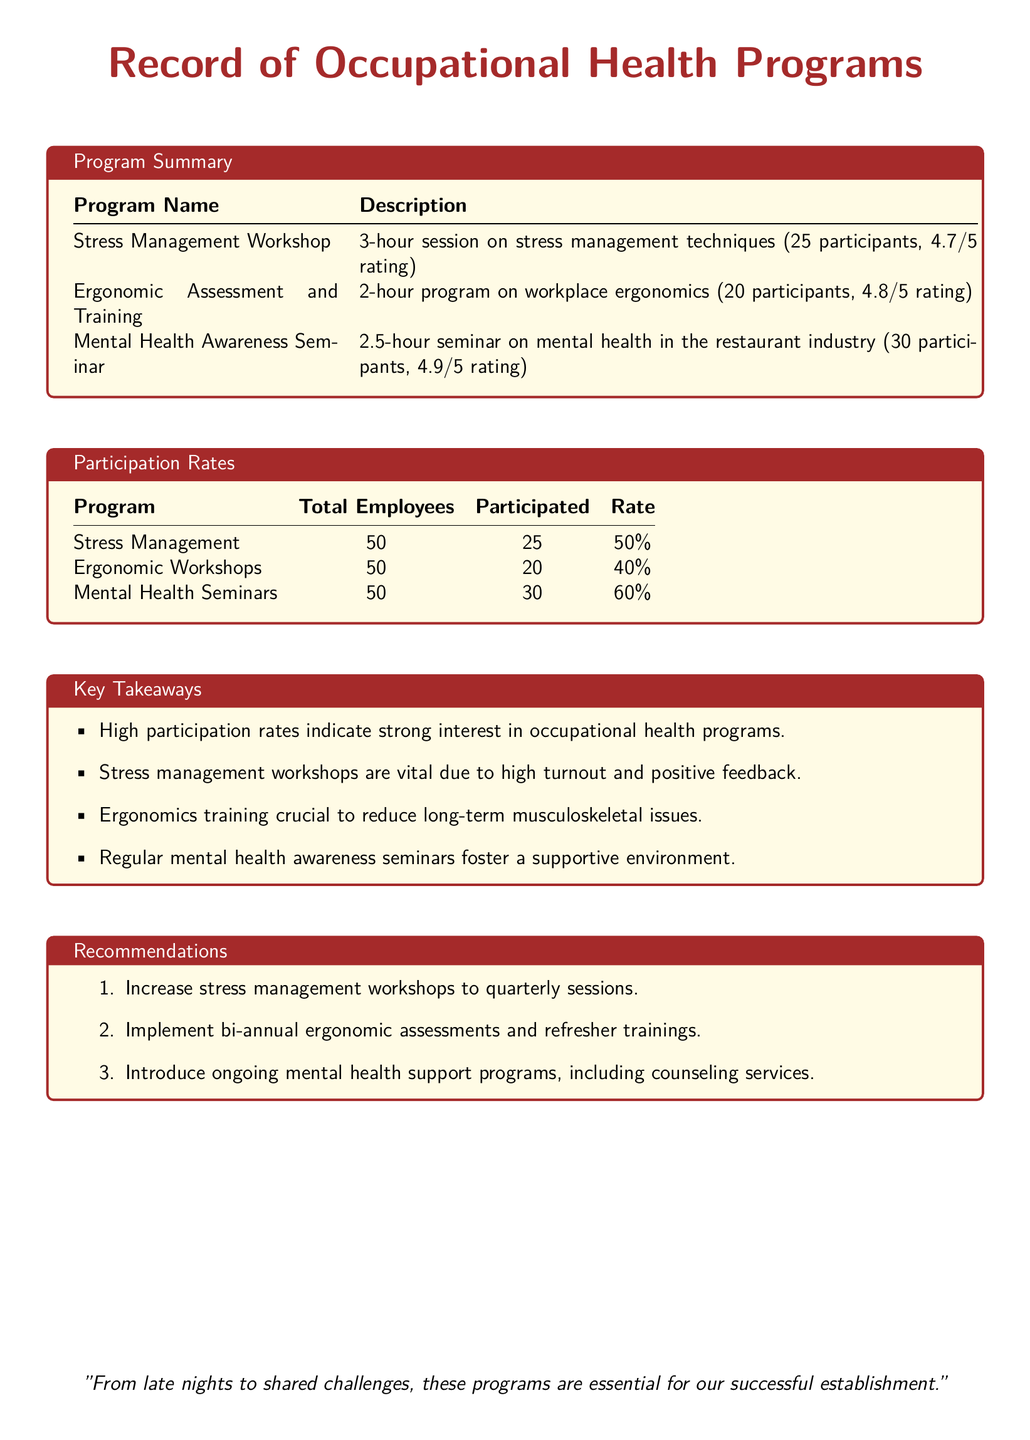what is the average rating of the Stress Management Workshop? The average rating of the Stress Management Workshop is given as 4.7 out of 5 in the document.
Answer: 4.7/5 how many participants attended the Ergonomic Workshops? The document states that there were 20 participants in the Ergonomic Workshops.
Answer: 20 what is the participation rate for Mental Health Seminars? The participation rate for Mental Health Seminars is noted as 60% in the participation rates section.
Answer: 60% which program had the highest rating? The program with the highest rating is the Mental Health Awareness Seminar at 4.9 out of 5.
Answer: 4.9/5 how often should stress management workshops be held according to the recommendations? According to the recommendations, stress management workshops should be held quarterly.
Answer: quarterly how many total employees participated in Stress Management? The total number of employees participating in the Stress Management program is 25 according to the participation rates.
Answer: 25 what is a key takeaway regarding ergonomics training? A key takeaway regarding ergonomics training is that it is crucial to reduce long-term musculoskeletal issues.
Answer: reduce long-term musculoskeletal issues what is the total number of employees across all programs? The total number of employees for each program is 50, leading to a total of 150 employees across all programs.
Answer: 150 